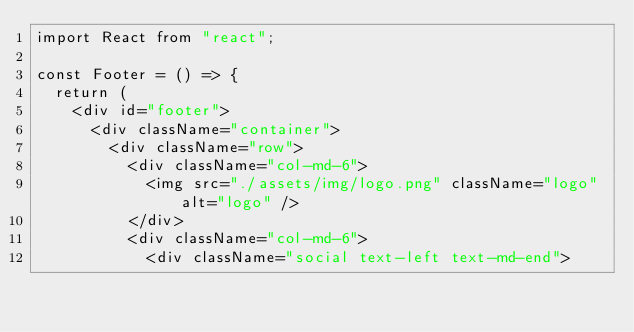Convert code to text. <code><loc_0><loc_0><loc_500><loc_500><_TypeScript_>import React from "react";

const Footer = () => {
  return (
    <div id="footer">
      <div className="container">
        <div className="row">
          <div className="col-md-6">
            <img src="./assets/img/logo.png" className="logo" alt="logo" />
          </div>
          <div className="col-md-6">
            <div className="social text-left text-md-end"></code> 